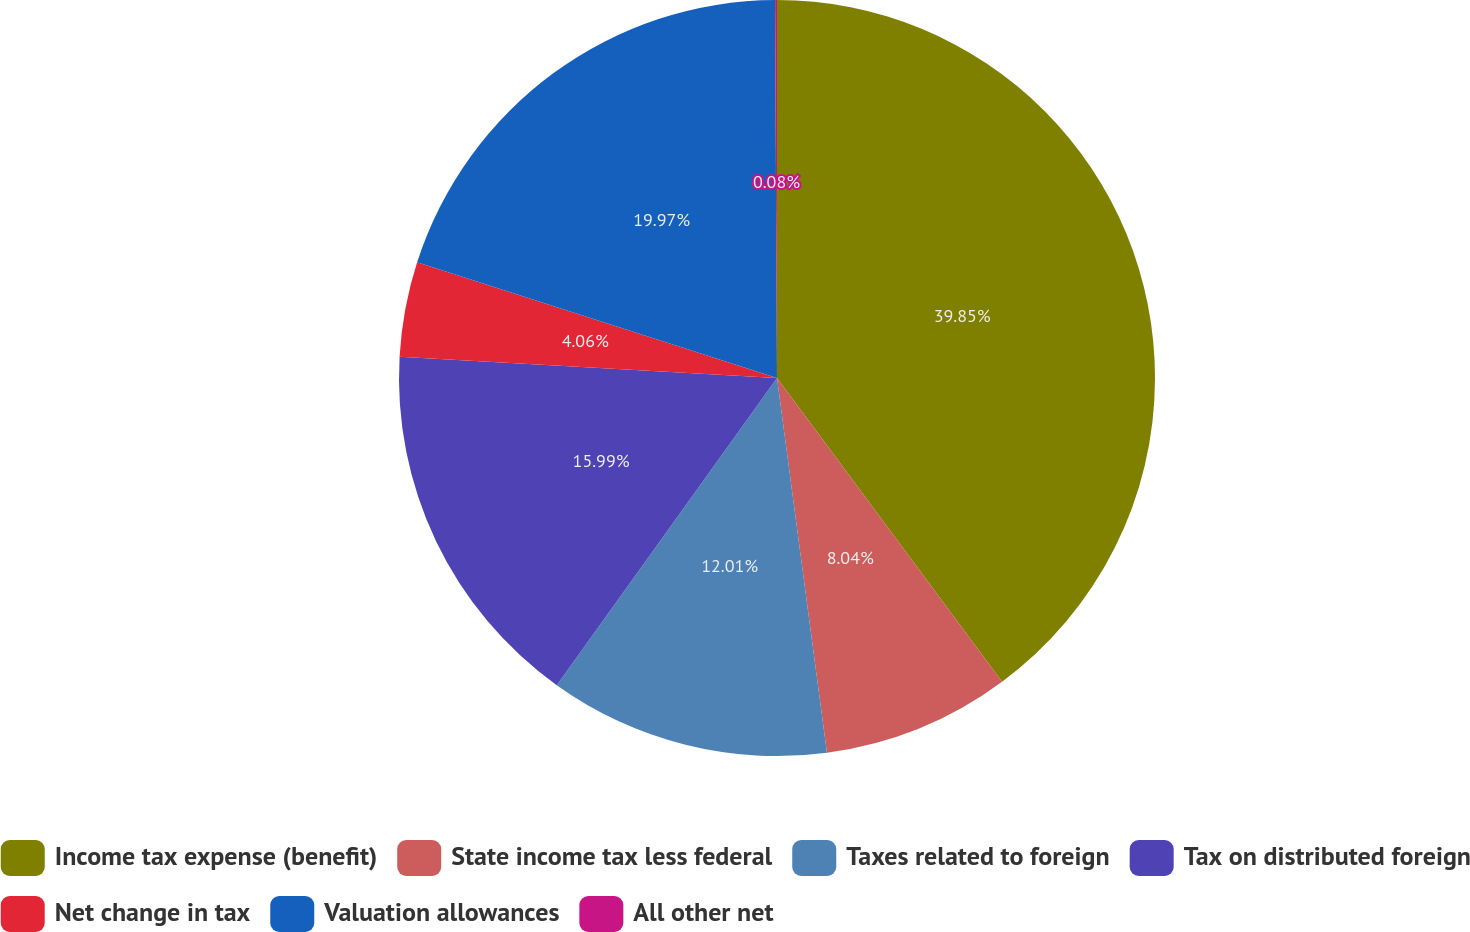Convert chart to OTSL. <chart><loc_0><loc_0><loc_500><loc_500><pie_chart><fcel>Income tax expense (benefit)<fcel>State income tax less federal<fcel>Taxes related to foreign<fcel>Tax on distributed foreign<fcel>Net change in tax<fcel>Valuation allowances<fcel>All other net<nl><fcel>39.85%<fcel>8.04%<fcel>12.01%<fcel>15.99%<fcel>4.06%<fcel>19.97%<fcel>0.08%<nl></chart> 